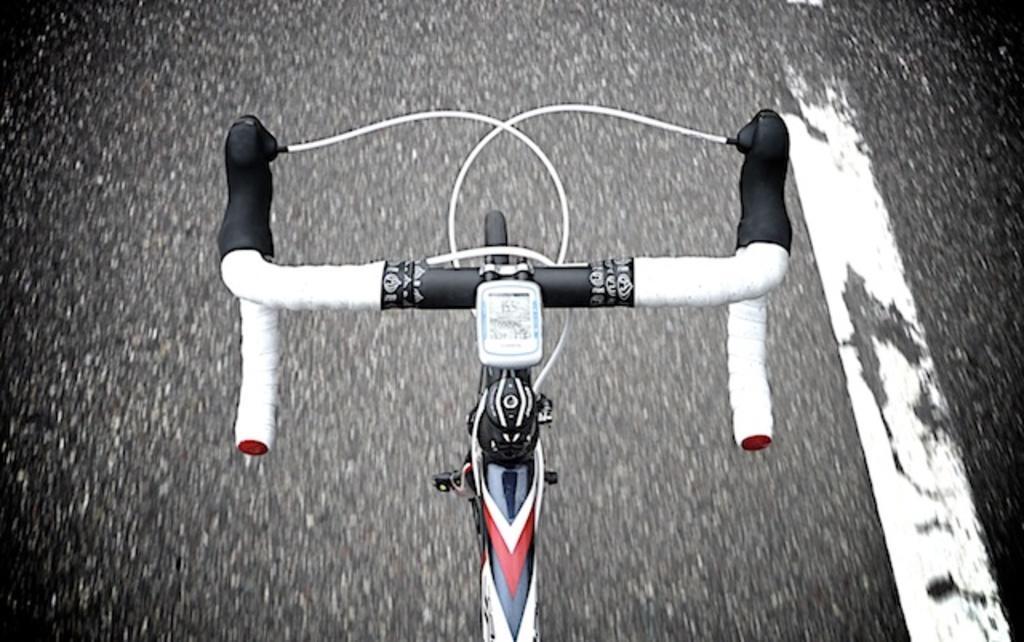Could you give a brief overview of what you see in this image? In this image there is a cycle on a road. 